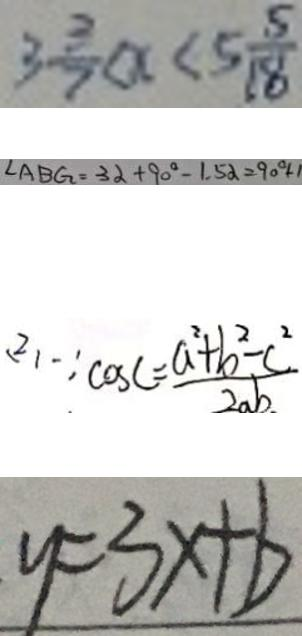<formula> <loc_0><loc_0><loc_500><loc_500>3 \frac { 3 } { 7 } < x < 5 \frac { 5 } { 1 8 } 
 \angle A B G = 3 \alpha + 9 0 ^ { \circ } - 1 . 5 \alpha = 9 0 ^ { \circ } + 1 
 ( 2 ) \because \cos C = \frac { a ^ { 2 } + b ^ { 2 } - c ^ { 2 } } { 2 a b } 
 y = 3 x + b</formula> 